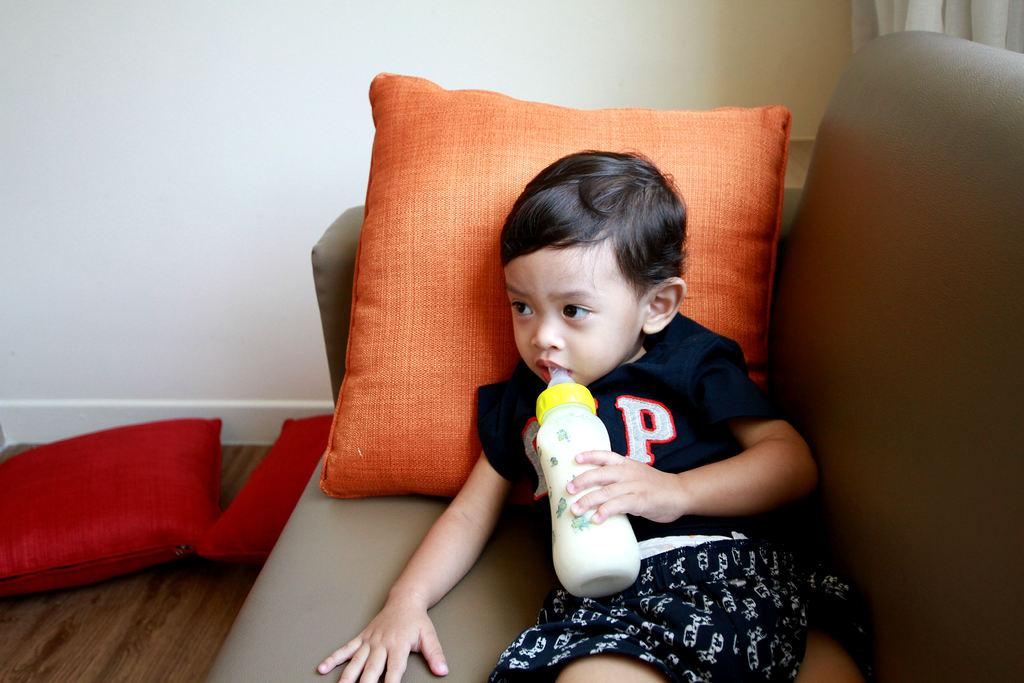What is the main subject of the image? There is a child in the image. What is the child doing in the image? The child is lying on a couch. What is the child holding in his hand? The child is holding a bottle in his hand. What can be seen in the left corner of the image? There are pillows in the left corner of the image. What is visible in the background of the image? There is a wall and a curtain in the background of the image. What type of house is visible in the background of the image? There is no house visible in the background of the image; only a wall and a curtain are present. Is the child in the image planning an attack on someone? There is no indication in the image that the child is planning an attack on anyone. 